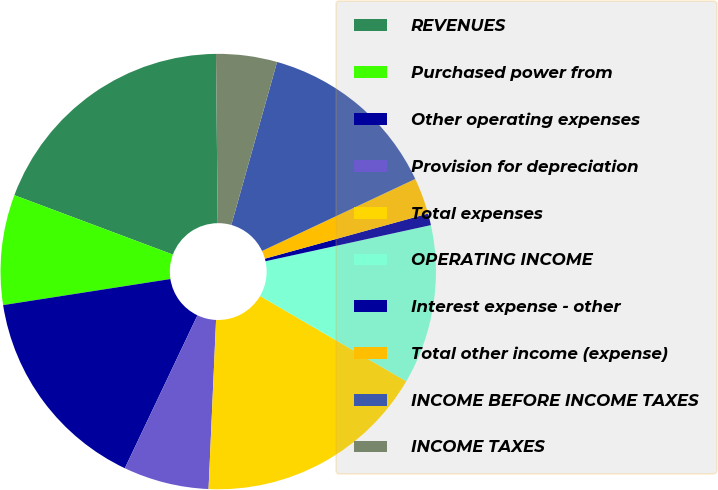<chart> <loc_0><loc_0><loc_500><loc_500><pie_chart><fcel>REVENUES<fcel>Purchased power from<fcel>Other operating expenses<fcel>Provision for depreciation<fcel>Total expenses<fcel>OPERATING INCOME<fcel>Interest expense - other<fcel>Total other income (expense)<fcel>INCOME BEFORE INCOME TAXES<fcel>INCOME TAXES<nl><fcel>19.13%<fcel>8.17%<fcel>15.48%<fcel>6.35%<fcel>17.3%<fcel>11.83%<fcel>0.87%<fcel>2.7%<fcel>13.65%<fcel>4.52%<nl></chart> 